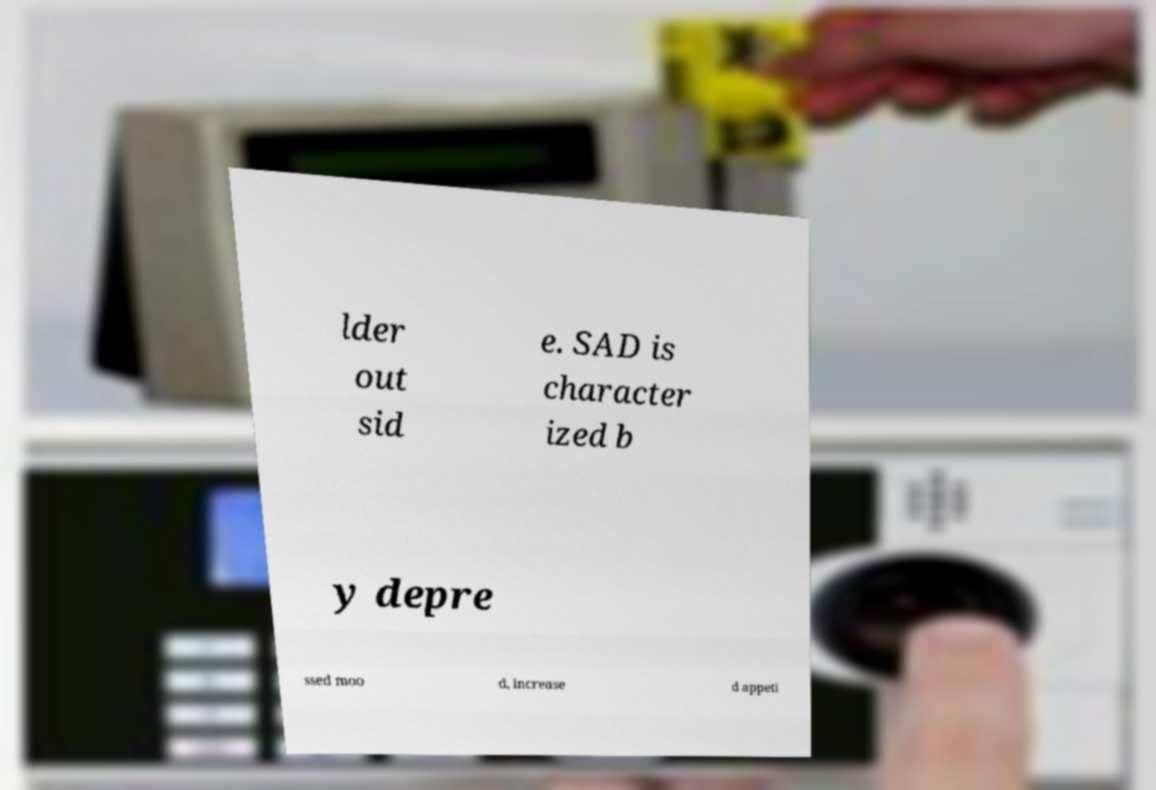What messages or text are displayed in this image? I need them in a readable, typed format. lder out sid e. SAD is character ized b y depre ssed moo d, increase d appeti 